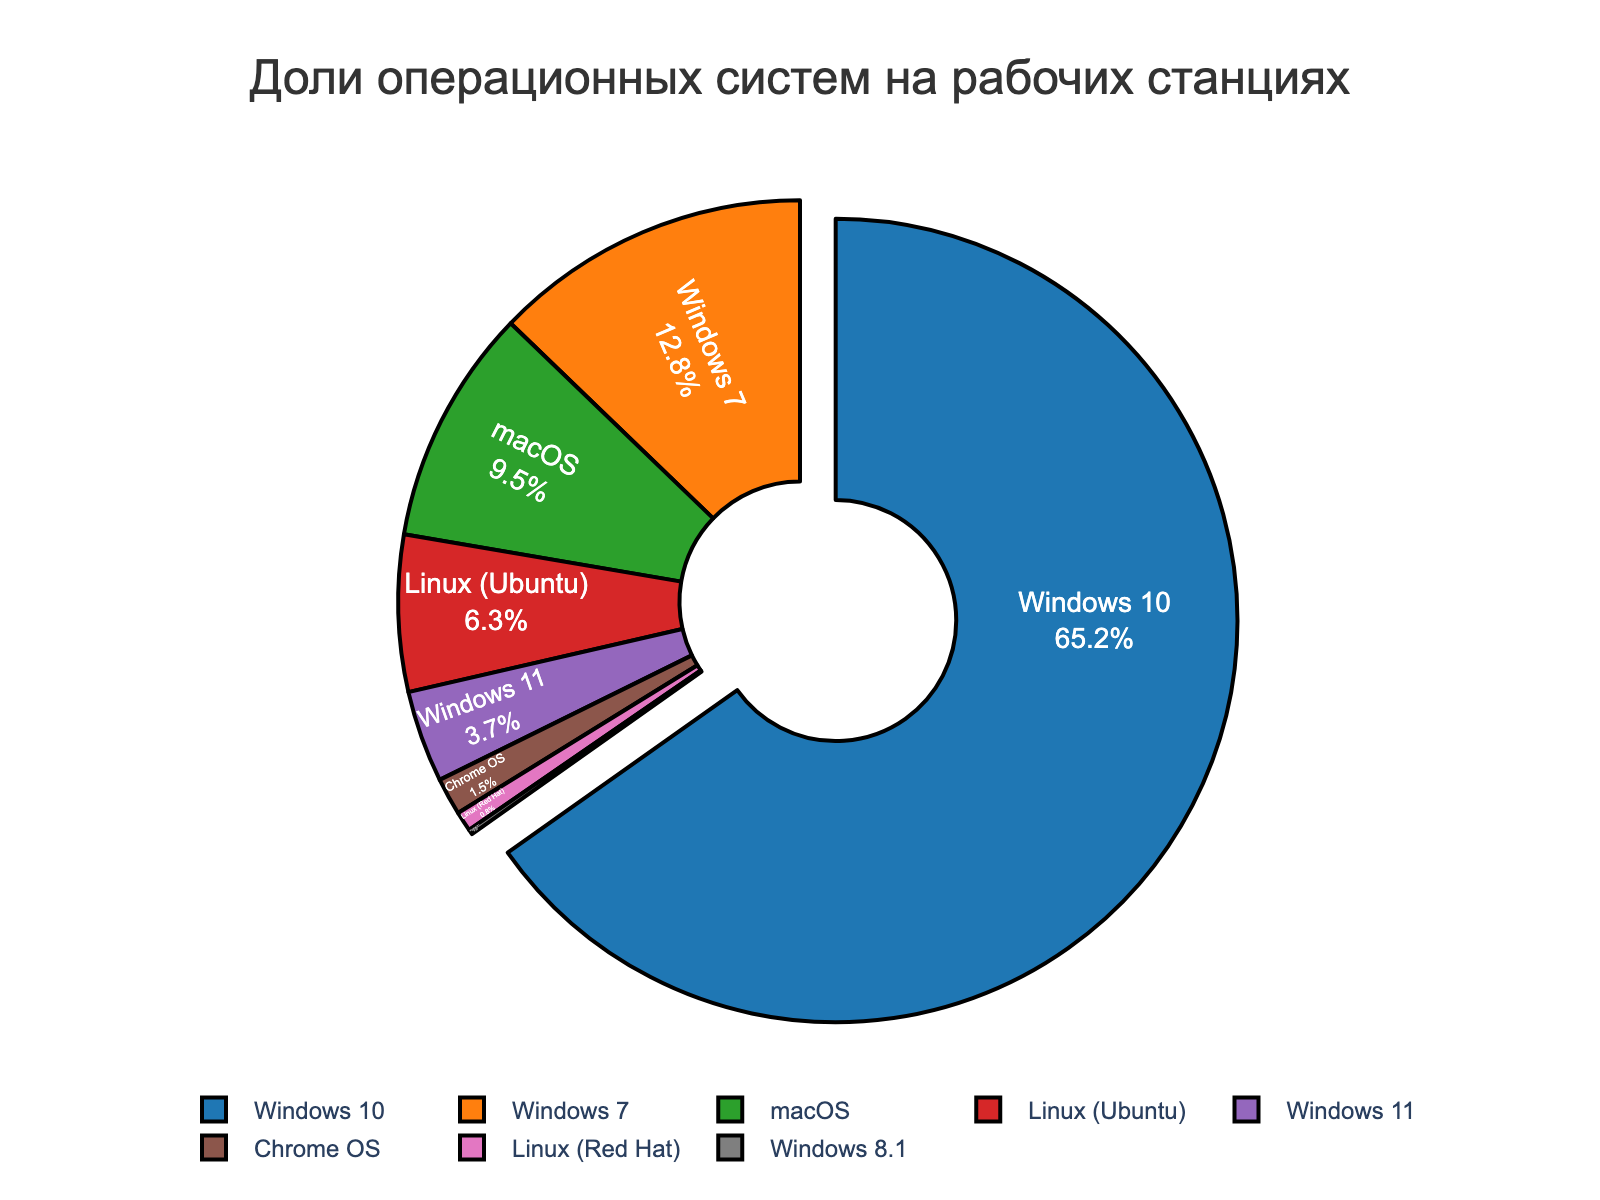How much more percentage share does Windows 10 have compared to Windows 7? To find how much more percentage share Windows 10 has compared to Windows 7, subtract the percentage of Windows 7 from Windows 10. Windows 10 has 65.2% and Windows 7 has 12.8%, so 65.2 - 12.8 = 52.4
Answer: 52.4 What percentage of workstations run on a version of Windows (including Windows 10, 7, 11, 8.1)? Add the percentages of all Windows versions. Windows 10 (65.2%), Windows 7 (12.8%), Windows 11 (3.7%), and Windows 8.1 (0.2%) sum up to 65.2 + 12.8 + 3.7 + 0.2 = 81.9
Answer: 81.9 Which operating system has the smallest share? By looking at the plotted figure, the smallest slice would represent the operating system with the smallest share. In this case, Windows 8.1 has the smallest share, which is 0.2%.
Answer: Windows 8.1 Compare the combined percentage of Linux distributions (Ubuntu and Red Hat) to macOS. Which one is higher? First, sum the Linux distributions' percentages (Ubuntu and Red Hat): 6.3 + 0.8 = 7.1. Compare with macOS, which is 9.5%. Since 9.5% (macOS) is greater than 7.1% (Linux distributions), macOS has a higher percentage.
Answer: macOS What is the total percentage of workstations running non-Windows operating systems? Subtract the combined percentage of all Windows operating systems from 100%. Windows OS combined is 81.9%, so 100 - 81.9 = 18.1% non-Windows operating systems.
Answer: 18.1 How does the share of Chrome OS compare to the combined share of Linux (Ubuntu + Red Hat)? Calculate the combined share of Linux first: Linux distributions' total = 6.3 + 0.8 = 7.1. Compare it with Chrome OS which is 1.5%. Thus, 7.1% (Linux) is greater than 1.5% (Chrome OS).
Answer: Linux (Ubuntu + Red Hat) has a larger share Which operating system has been pulled out from the pie chart and why? The pulled out segment corresponds to the operating system with the highest percentage share. From the data, Windows 10 has the highest share at 65.2%, and it is visually pulled out in the pie chart to emphasize its dominance.
Answer: Windows 10 Find the difference between the total percentages of Linux systems and Windows 11. First, sum the percentages for the Linux systems: Ubuntu (6.3%) + Red Hat (0.8%) = 7.1%. Then subtract the percentage of Windows 11, which is 3.7%. So, 7.1 - 3.7 = 3.4.
Answer: 3.4 What is the average percentage share of all operating systems listed? There are eight operating systems listed. The total percentage is 100%, so the average percentage share is 100 / 8 = 12.5%.
Answer: 12.5 